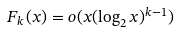<formula> <loc_0><loc_0><loc_500><loc_500>F _ { k } ( x ) = o ( x ( \log _ { 2 } x ) ^ { k - 1 } )</formula> 